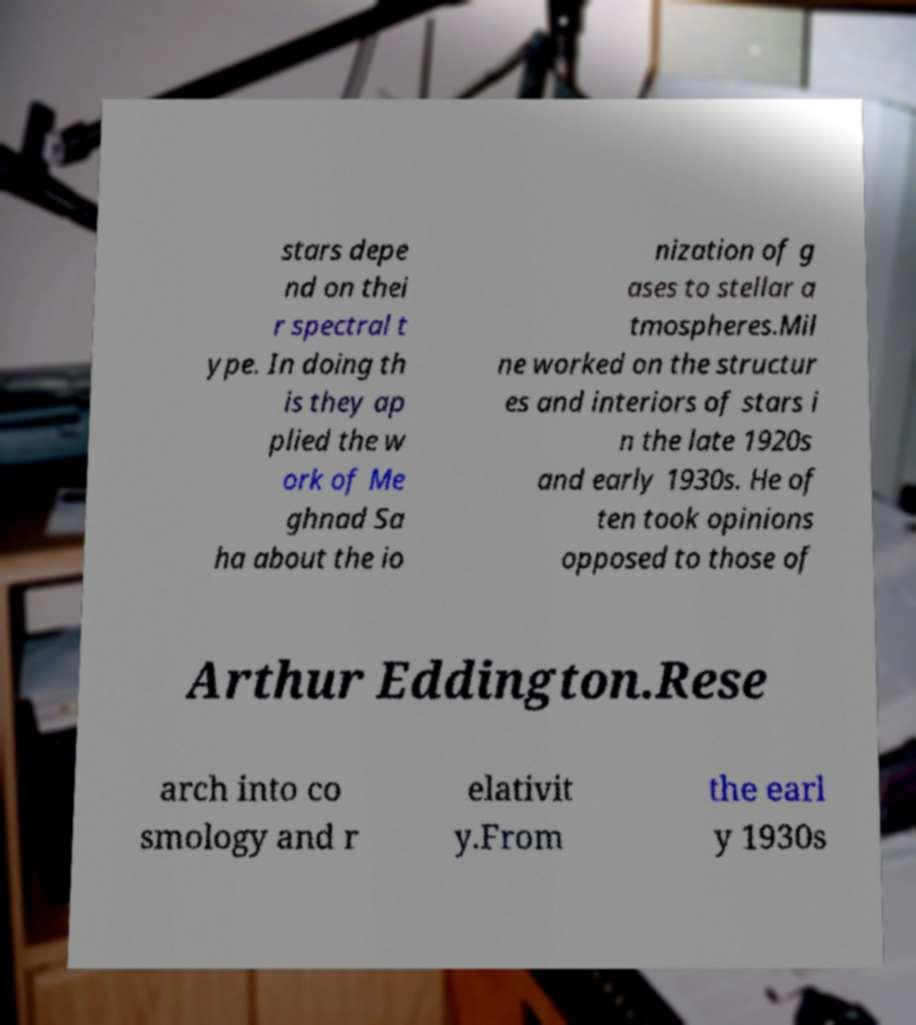Please read and relay the text visible in this image. What does it say? stars depe nd on thei r spectral t ype. In doing th is they ap plied the w ork of Me ghnad Sa ha about the io nization of g ases to stellar a tmospheres.Mil ne worked on the structur es and interiors of stars i n the late 1920s and early 1930s. He of ten took opinions opposed to those of Arthur Eddington.Rese arch into co smology and r elativit y.From the earl y 1930s 